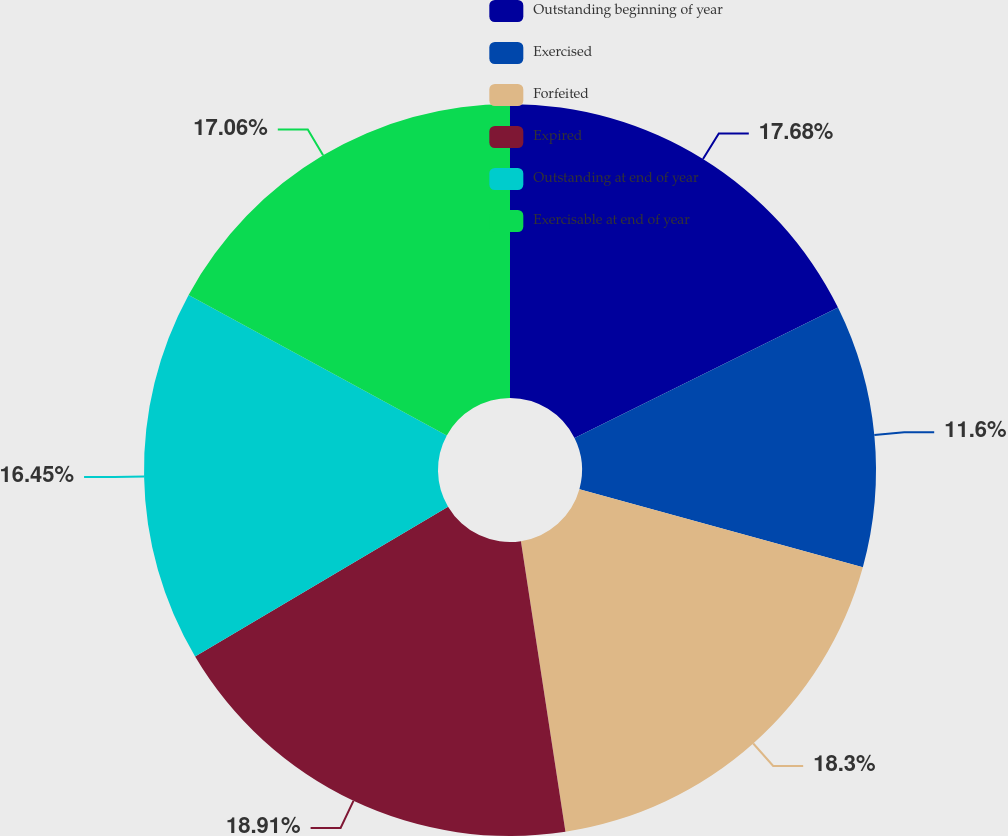Convert chart to OTSL. <chart><loc_0><loc_0><loc_500><loc_500><pie_chart><fcel>Outstanding beginning of year<fcel>Exercised<fcel>Forfeited<fcel>Expired<fcel>Outstanding at end of year<fcel>Exercisable at end of year<nl><fcel>17.68%<fcel>11.6%<fcel>18.3%<fcel>18.91%<fcel>16.45%<fcel>17.06%<nl></chart> 